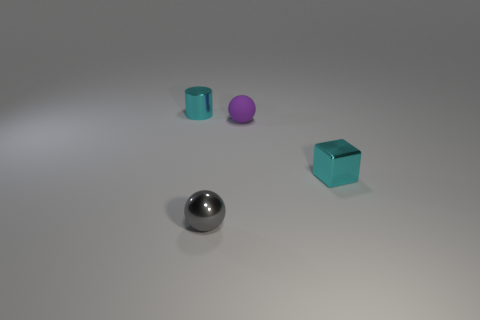There is a small matte object on the right side of the thing that is left of the ball in front of the purple object; what color is it?
Give a very brief answer. Purple. Are there an equal number of cyan objects that are behind the small cyan metal cylinder and small blocks left of the small gray metal thing?
Keep it short and to the point. Yes. There is another gray thing that is the same size as the rubber thing; what is its shape?
Your answer should be very brief. Sphere. Are there any small things that have the same color as the tiny block?
Make the answer very short. Yes. The small cyan object on the left side of the cyan metal cube has what shape?
Provide a succinct answer. Cylinder. What color is the block?
Your response must be concise. Cyan. There is a tiny cylinder that is made of the same material as the gray sphere; what is its color?
Give a very brief answer. Cyan. How many small gray things have the same material as the cyan cube?
Your answer should be very brief. 1. There is a shiny ball; how many metal blocks are in front of it?
Keep it short and to the point. 0. Are the tiny object that is to the left of the tiny gray thing and the tiny cyan object right of the shiny ball made of the same material?
Ensure brevity in your answer.  Yes. 